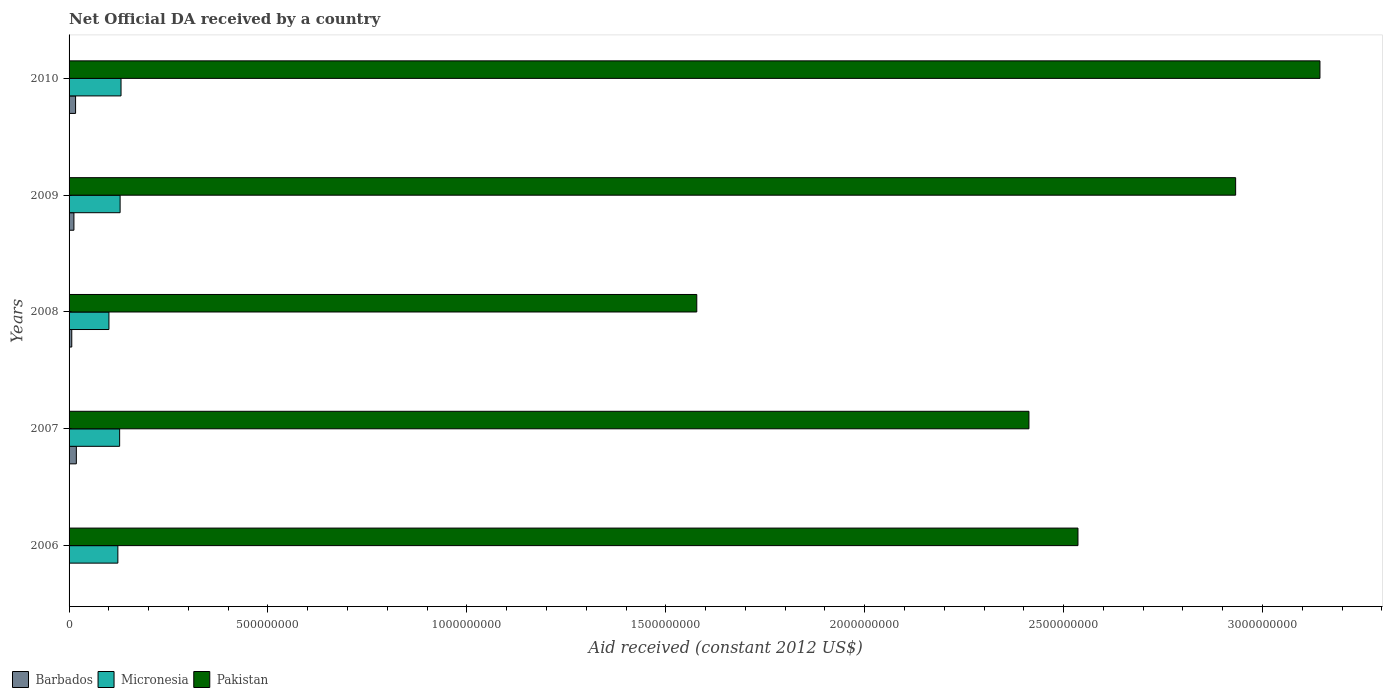How many different coloured bars are there?
Ensure brevity in your answer.  3. How many bars are there on the 4th tick from the top?
Your answer should be very brief. 3. How many bars are there on the 3rd tick from the bottom?
Provide a short and direct response. 3. What is the net official development assistance aid received in Barbados in 2008?
Offer a very short reply. 6.78e+06. Across all years, what is the maximum net official development assistance aid received in Micronesia?
Make the answer very short. 1.31e+08. Across all years, what is the minimum net official development assistance aid received in Barbados?
Offer a terse response. 0. What is the total net official development assistance aid received in Barbados in the graph?
Your answer should be compact. 5.36e+07. What is the difference between the net official development assistance aid received in Micronesia in 2007 and that in 2009?
Keep it short and to the point. -1.18e+06. What is the difference between the net official development assistance aid received in Barbados in 2006 and the net official development assistance aid received in Pakistan in 2007?
Keep it short and to the point. -2.41e+09. What is the average net official development assistance aid received in Pakistan per year?
Keep it short and to the point. 2.52e+09. In the year 2009, what is the difference between the net official development assistance aid received in Barbados and net official development assistance aid received in Pakistan?
Your response must be concise. -2.92e+09. In how many years, is the net official development assistance aid received in Barbados greater than 1100000000 US$?
Keep it short and to the point. 0. What is the ratio of the net official development assistance aid received in Micronesia in 2006 to that in 2007?
Ensure brevity in your answer.  0.96. Is the net official development assistance aid received in Barbados in 2007 less than that in 2009?
Your answer should be compact. No. Is the difference between the net official development assistance aid received in Barbados in 2007 and 2008 greater than the difference between the net official development assistance aid received in Pakistan in 2007 and 2008?
Give a very brief answer. No. What is the difference between the highest and the second highest net official development assistance aid received in Micronesia?
Make the answer very short. 2.29e+06. What is the difference between the highest and the lowest net official development assistance aid received in Barbados?
Your answer should be compact. 1.83e+07. Is the sum of the net official development assistance aid received in Pakistan in 2006 and 2009 greater than the maximum net official development assistance aid received in Micronesia across all years?
Offer a terse response. Yes. Is it the case that in every year, the sum of the net official development assistance aid received in Micronesia and net official development assistance aid received in Pakistan is greater than the net official development assistance aid received in Barbados?
Make the answer very short. Yes. How many bars are there?
Keep it short and to the point. 14. Are all the bars in the graph horizontal?
Offer a terse response. Yes. Does the graph contain any zero values?
Give a very brief answer. Yes. How many legend labels are there?
Your answer should be compact. 3. What is the title of the graph?
Make the answer very short. Net Official DA received by a country. What is the label or title of the X-axis?
Keep it short and to the point. Aid received (constant 2012 US$). What is the Aid received (constant 2012 US$) in Micronesia in 2006?
Make the answer very short. 1.23e+08. What is the Aid received (constant 2012 US$) in Pakistan in 2006?
Provide a short and direct response. 2.54e+09. What is the Aid received (constant 2012 US$) of Barbados in 2007?
Your answer should be compact. 1.83e+07. What is the Aid received (constant 2012 US$) in Micronesia in 2007?
Ensure brevity in your answer.  1.27e+08. What is the Aid received (constant 2012 US$) of Pakistan in 2007?
Your response must be concise. 2.41e+09. What is the Aid received (constant 2012 US$) of Barbados in 2008?
Your answer should be very brief. 6.78e+06. What is the Aid received (constant 2012 US$) of Micronesia in 2008?
Provide a short and direct response. 1.00e+08. What is the Aid received (constant 2012 US$) in Pakistan in 2008?
Your response must be concise. 1.58e+09. What is the Aid received (constant 2012 US$) in Barbados in 2009?
Make the answer very short. 1.22e+07. What is the Aid received (constant 2012 US$) of Micronesia in 2009?
Your answer should be very brief. 1.28e+08. What is the Aid received (constant 2012 US$) of Pakistan in 2009?
Provide a succinct answer. 2.93e+09. What is the Aid received (constant 2012 US$) in Barbados in 2010?
Give a very brief answer. 1.64e+07. What is the Aid received (constant 2012 US$) in Micronesia in 2010?
Your response must be concise. 1.31e+08. What is the Aid received (constant 2012 US$) of Pakistan in 2010?
Offer a very short reply. 3.14e+09. Across all years, what is the maximum Aid received (constant 2012 US$) of Barbados?
Make the answer very short. 1.83e+07. Across all years, what is the maximum Aid received (constant 2012 US$) of Micronesia?
Provide a succinct answer. 1.31e+08. Across all years, what is the maximum Aid received (constant 2012 US$) in Pakistan?
Ensure brevity in your answer.  3.14e+09. Across all years, what is the minimum Aid received (constant 2012 US$) of Micronesia?
Provide a short and direct response. 1.00e+08. Across all years, what is the minimum Aid received (constant 2012 US$) of Pakistan?
Ensure brevity in your answer.  1.58e+09. What is the total Aid received (constant 2012 US$) in Barbados in the graph?
Your answer should be very brief. 5.36e+07. What is the total Aid received (constant 2012 US$) of Micronesia in the graph?
Your response must be concise. 6.09e+08. What is the total Aid received (constant 2012 US$) in Pakistan in the graph?
Give a very brief answer. 1.26e+1. What is the difference between the Aid received (constant 2012 US$) in Micronesia in 2006 and that in 2007?
Offer a terse response. -4.48e+06. What is the difference between the Aid received (constant 2012 US$) of Pakistan in 2006 and that in 2007?
Offer a very short reply. 1.23e+08. What is the difference between the Aid received (constant 2012 US$) of Micronesia in 2006 and that in 2008?
Offer a very short reply. 2.24e+07. What is the difference between the Aid received (constant 2012 US$) of Pakistan in 2006 and that in 2008?
Provide a short and direct response. 9.58e+08. What is the difference between the Aid received (constant 2012 US$) in Micronesia in 2006 and that in 2009?
Make the answer very short. -5.66e+06. What is the difference between the Aid received (constant 2012 US$) in Pakistan in 2006 and that in 2009?
Make the answer very short. -3.96e+08. What is the difference between the Aid received (constant 2012 US$) in Micronesia in 2006 and that in 2010?
Keep it short and to the point. -7.95e+06. What is the difference between the Aid received (constant 2012 US$) of Pakistan in 2006 and that in 2010?
Offer a very short reply. -6.08e+08. What is the difference between the Aid received (constant 2012 US$) in Barbados in 2007 and that in 2008?
Ensure brevity in your answer.  1.15e+07. What is the difference between the Aid received (constant 2012 US$) in Micronesia in 2007 and that in 2008?
Your answer should be compact. 2.69e+07. What is the difference between the Aid received (constant 2012 US$) in Pakistan in 2007 and that in 2008?
Ensure brevity in your answer.  8.35e+08. What is the difference between the Aid received (constant 2012 US$) of Barbados in 2007 and that in 2009?
Provide a short and direct response. 6.12e+06. What is the difference between the Aid received (constant 2012 US$) of Micronesia in 2007 and that in 2009?
Provide a short and direct response. -1.18e+06. What is the difference between the Aid received (constant 2012 US$) of Pakistan in 2007 and that in 2009?
Offer a terse response. -5.20e+08. What is the difference between the Aid received (constant 2012 US$) of Barbados in 2007 and that in 2010?
Give a very brief answer. 1.93e+06. What is the difference between the Aid received (constant 2012 US$) in Micronesia in 2007 and that in 2010?
Ensure brevity in your answer.  -3.47e+06. What is the difference between the Aid received (constant 2012 US$) of Pakistan in 2007 and that in 2010?
Provide a succinct answer. -7.32e+08. What is the difference between the Aid received (constant 2012 US$) in Barbados in 2008 and that in 2009?
Ensure brevity in your answer.  -5.40e+06. What is the difference between the Aid received (constant 2012 US$) in Micronesia in 2008 and that in 2009?
Your answer should be compact. -2.81e+07. What is the difference between the Aid received (constant 2012 US$) in Pakistan in 2008 and that in 2009?
Give a very brief answer. -1.35e+09. What is the difference between the Aid received (constant 2012 US$) of Barbados in 2008 and that in 2010?
Keep it short and to the point. -9.59e+06. What is the difference between the Aid received (constant 2012 US$) in Micronesia in 2008 and that in 2010?
Make the answer very short. -3.04e+07. What is the difference between the Aid received (constant 2012 US$) of Pakistan in 2008 and that in 2010?
Ensure brevity in your answer.  -1.57e+09. What is the difference between the Aid received (constant 2012 US$) of Barbados in 2009 and that in 2010?
Your answer should be very brief. -4.19e+06. What is the difference between the Aid received (constant 2012 US$) in Micronesia in 2009 and that in 2010?
Your answer should be compact. -2.29e+06. What is the difference between the Aid received (constant 2012 US$) in Pakistan in 2009 and that in 2010?
Ensure brevity in your answer.  -2.12e+08. What is the difference between the Aid received (constant 2012 US$) of Micronesia in 2006 and the Aid received (constant 2012 US$) of Pakistan in 2007?
Ensure brevity in your answer.  -2.29e+09. What is the difference between the Aid received (constant 2012 US$) in Micronesia in 2006 and the Aid received (constant 2012 US$) in Pakistan in 2008?
Give a very brief answer. -1.46e+09. What is the difference between the Aid received (constant 2012 US$) in Micronesia in 2006 and the Aid received (constant 2012 US$) in Pakistan in 2009?
Offer a terse response. -2.81e+09. What is the difference between the Aid received (constant 2012 US$) of Micronesia in 2006 and the Aid received (constant 2012 US$) of Pakistan in 2010?
Provide a succinct answer. -3.02e+09. What is the difference between the Aid received (constant 2012 US$) in Barbados in 2007 and the Aid received (constant 2012 US$) in Micronesia in 2008?
Offer a terse response. -8.19e+07. What is the difference between the Aid received (constant 2012 US$) in Barbados in 2007 and the Aid received (constant 2012 US$) in Pakistan in 2008?
Make the answer very short. -1.56e+09. What is the difference between the Aid received (constant 2012 US$) in Micronesia in 2007 and the Aid received (constant 2012 US$) in Pakistan in 2008?
Your answer should be compact. -1.45e+09. What is the difference between the Aid received (constant 2012 US$) of Barbados in 2007 and the Aid received (constant 2012 US$) of Micronesia in 2009?
Offer a very short reply. -1.10e+08. What is the difference between the Aid received (constant 2012 US$) in Barbados in 2007 and the Aid received (constant 2012 US$) in Pakistan in 2009?
Make the answer very short. -2.91e+09. What is the difference between the Aid received (constant 2012 US$) in Micronesia in 2007 and the Aid received (constant 2012 US$) in Pakistan in 2009?
Keep it short and to the point. -2.81e+09. What is the difference between the Aid received (constant 2012 US$) in Barbados in 2007 and the Aid received (constant 2012 US$) in Micronesia in 2010?
Provide a succinct answer. -1.12e+08. What is the difference between the Aid received (constant 2012 US$) of Barbados in 2007 and the Aid received (constant 2012 US$) of Pakistan in 2010?
Provide a succinct answer. -3.13e+09. What is the difference between the Aid received (constant 2012 US$) in Micronesia in 2007 and the Aid received (constant 2012 US$) in Pakistan in 2010?
Keep it short and to the point. -3.02e+09. What is the difference between the Aid received (constant 2012 US$) in Barbados in 2008 and the Aid received (constant 2012 US$) in Micronesia in 2009?
Your response must be concise. -1.22e+08. What is the difference between the Aid received (constant 2012 US$) in Barbados in 2008 and the Aid received (constant 2012 US$) in Pakistan in 2009?
Your answer should be very brief. -2.93e+09. What is the difference between the Aid received (constant 2012 US$) of Micronesia in 2008 and the Aid received (constant 2012 US$) of Pakistan in 2009?
Provide a short and direct response. -2.83e+09. What is the difference between the Aid received (constant 2012 US$) in Barbados in 2008 and the Aid received (constant 2012 US$) in Micronesia in 2010?
Offer a terse response. -1.24e+08. What is the difference between the Aid received (constant 2012 US$) in Barbados in 2008 and the Aid received (constant 2012 US$) in Pakistan in 2010?
Make the answer very short. -3.14e+09. What is the difference between the Aid received (constant 2012 US$) of Micronesia in 2008 and the Aid received (constant 2012 US$) of Pakistan in 2010?
Give a very brief answer. -3.04e+09. What is the difference between the Aid received (constant 2012 US$) of Barbados in 2009 and the Aid received (constant 2012 US$) of Micronesia in 2010?
Ensure brevity in your answer.  -1.18e+08. What is the difference between the Aid received (constant 2012 US$) of Barbados in 2009 and the Aid received (constant 2012 US$) of Pakistan in 2010?
Offer a terse response. -3.13e+09. What is the difference between the Aid received (constant 2012 US$) of Micronesia in 2009 and the Aid received (constant 2012 US$) of Pakistan in 2010?
Your answer should be very brief. -3.02e+09. What is the average Aid received (constant 2012 US$) of Barbados per year?
Ensure brevity in your answer.  1.07e+07. What is the average Aid received (constant 2012 US$) in Micronesia per year?
Give a very brief answer. 1.22e+08. What is the average Aid received (constant 2012 US$) of Pakistan per year?
Your response must be concise. 2.52e+09. In the year 2006, what is the difference between the Aid received (constant 2012 US$) in Micronesia and Aid received (constant 2012 US$) in Pakistan?
Offer a very short reply. -2.41e+09. In the year 2007, what is the difference between the Aid received (constant 2012 US$) of Barbados and Aid received (constant 2012 US$) of Micronesia?
Your answer should be compact. -1.09e+08. In the year 2007, what is the difference between the Aid received (constant 2012 US$) of Barbados and Aid received (constant 2012 US$) of Pakistan?
Your response must be concise. -2.39e+09. In the year 2007, what is the difference between the Aid received (constant 2012 US$) of Micronesia and Aid received (constant 2012 US$) of Pakistan?
Provide a succinct answer. -2.29e+09. In the year 2008, what is the difference between the Aid received (constant 2012 US$) in Barbados and Aid received (constant 2012 US$) in Micronesia?
Give a very brief answer. -9.34e+07. In the year 2008, what is the difference between the Aid received (constant 2012 US$) in Barbados and Aid received (constant 2012 US$) in Pakistan?
Ensure brevity in your answer.  -1.57e+09. In the year 2008, what is the difference between the Aid received (constant 2012 US$) of Micronesia and Aid received (constant 2012 US$) of Pakistan?
Ensure brevity in your answer.  -1.48e+09. In the year 2009, what is the difference between the Aid received (constant 2012 US$) in Barbados and Aid received (constant 2012 US$) in Micronesia?
Ensure brevity in your answer.  -1.16e+08. In the year 2009, what is the difference between the Aid received (constant 2012 US$) in Barbados and Aid received (constant 2012 US$) in Pakistan?
Give a very brief answer. -2.92e+09. In the year 2009, what is the difference between the Aid received (constant 2012 US$) in Micronesia and Aid received (constant 2012 US$) in Pakistan?
Your answer should be very brief. -2.80e+09. In the year 2010, what is the difference between the Aid received (constant 2012 US$) in Barbados and Aid received (constant 2012 US$) in Micronesia?
Your answer should be compact. -1.14e+08. In the year 2010, what is the difference between the Aid received (constant 2012 US$) of Barbados and Aid received (constant 2012 US$) of Pakistan?
Your answer should be very brief. -3.13e+09. In the year 2010, what is the difference between the Aid received (constant 2012 US$) of Micronesia and Aid received (constant 2012 US$) of Pakistan?
Give a very brief answer. -3.01e+09. What is the ratio of the Aid received (constant 2012 US$) of Micronesia in 2006 to that in 2007?
Provide a succinct answer. 0.96. What is the ratio of the Aid received (constant 2012 US$) of Pakistan in 2006 to that in 2007?
Provide a succinct answer. 1.05. What is the ratio of the Aid received (constant 2012 US$) in Micronesia in 2006 to that in 2008?
Your response must be concise. 1.22. What is the ratio of the Aid received (constant 2012 US$) in Pakistan in 2006 to that in 2008?
Offer a very short reply. 1.61. What is the ratio of the Aid received (constant 2012 US$) of Micronesia in 2006 to that in 2009?
Make the answer very short. 0.96. What is the ratio of the Aid received (constant 2012 US$) of Pakistan in 2006 to that in 2009?
Your answer should be very brief. 0.86. What is the ratio of the Aid received (constant 2012 US$) in Micronesia in 2006 to that in 2010?
Offer a very short reply. 0.94. What is the ratio of the Aid received (constant 2012 US$) in Pakistan in 2006 to that in 2010?
Provide a succinct answer. 0.81. What is the ratio of the Aid received (constant 2012 US$) of Barbados in 2007 to that in 2008?
Keep it short and to the point. 2.7. What is the ratio of the Aid received (constant 2012 US$) in Micronesia in 2007 to that in 2008?
Give a very brief answer. 1.27. What is the ratio of the Aid received (constant 2012 US$) in Pakistan in 2007 to that in 2008?
Keep it short and to the point. 1.53. What is the ratio of the Aid received (constant 2012 US$) of Barbados in 2007 to that in 2009?
Your answer should be compact. 1.5. What is the ratio of the Aid received (constant 2012 US$) in Micronesia in 2007 to that in 2009?
Provide a short and direct response. 0.99. What is the ratio of the Aid received (constant 2012 US$) in Pakistan in 2007 to that in 2009?
Ensure brevity in your answer.  0.82. What is the ratio of the Aid received (constant 2012 US$) of Barbados in 2007 to that in 2010?
Make the answer very short. 1.12. What is the ratio of the Aid received (constant 2012 US$) in Micronesia in 2007 to that in 2010?
Offer a very short reply. 0.97. What is the ratio of the Aid received (constant 2012 US$) of Pakistan in 2007 to that in 2010?
Your response must be concise. 0.77. What is the ratio of the Aid received (constant 2012 US$) in Barbados in 2008 to that in 2009?
Provide a succinct answer. 0.56. What is the ratio of the Aid received (constant 2012 US$) in Micronesia in 2008 to that in 2009?
Keep it short and to the point. 0.78. What is the ratio of the Aid received (constant 2012 US$) of Pakistan in 2008 to that in 2009?
Keep it short and to the point. 0.54. What is the ratio of the Aid received (constant 2012 US$) of Barbados in 2008 to that in 2010?
Make the answer very short. 0.41. What is the ratio of the Aid received (constant 2012 US$) in Micronesia in 2008 to that in 2010?
Offer a very short reply. 0.77. What is the ratio of the Aid received (constant 2012 US$) of Pakistan in 2008 to that in 2010?
Provide a succinct answer. 0.5. What is the ratio of the Aid received (constant 2012 US$) of Barbados in 2009 to that in 2010?
Ensure brevity in your answer.  0.74. What is the ratio of the Aid received (constant 2012 US$) of Micronesia in 2009 to that in 2010?
Ensure brevity in your answer.  0.98. What is the ratio of the Aid received (constant 2012 US$) in Pakistan in 2009 to that in 2010?
Provide a succinct answer. 0.93. What is the difference between the highest and the second highest Aid received (constant 2012 US$) of Barbados?
Make the answer very short. 1.93e+06. What is the difference between the highest and the second highest Aid received (constant 2012 US$) in Micronesia?
Offer a very short reply. 2.29e+06. What is the difference between the highest and the second highest Aid received (constant 2012 US$) in Pakistan?
Keep it short and to the point. 2.12e+08. What is the difference between the highest and the lowest Aid received (constant 2012 US$) in Barbados?
Offer a very short reply. 1.83e+07. What is the difference between the highest and the lowest Aid received (constant 2012 US$) in Micronesia?
Your response must be concise. 3.04e+07. What is the difference between the highest and the lowest Aid received (constant 2012 US$) of Pakistan?
Your answer should be compact. 1.57e+09. 